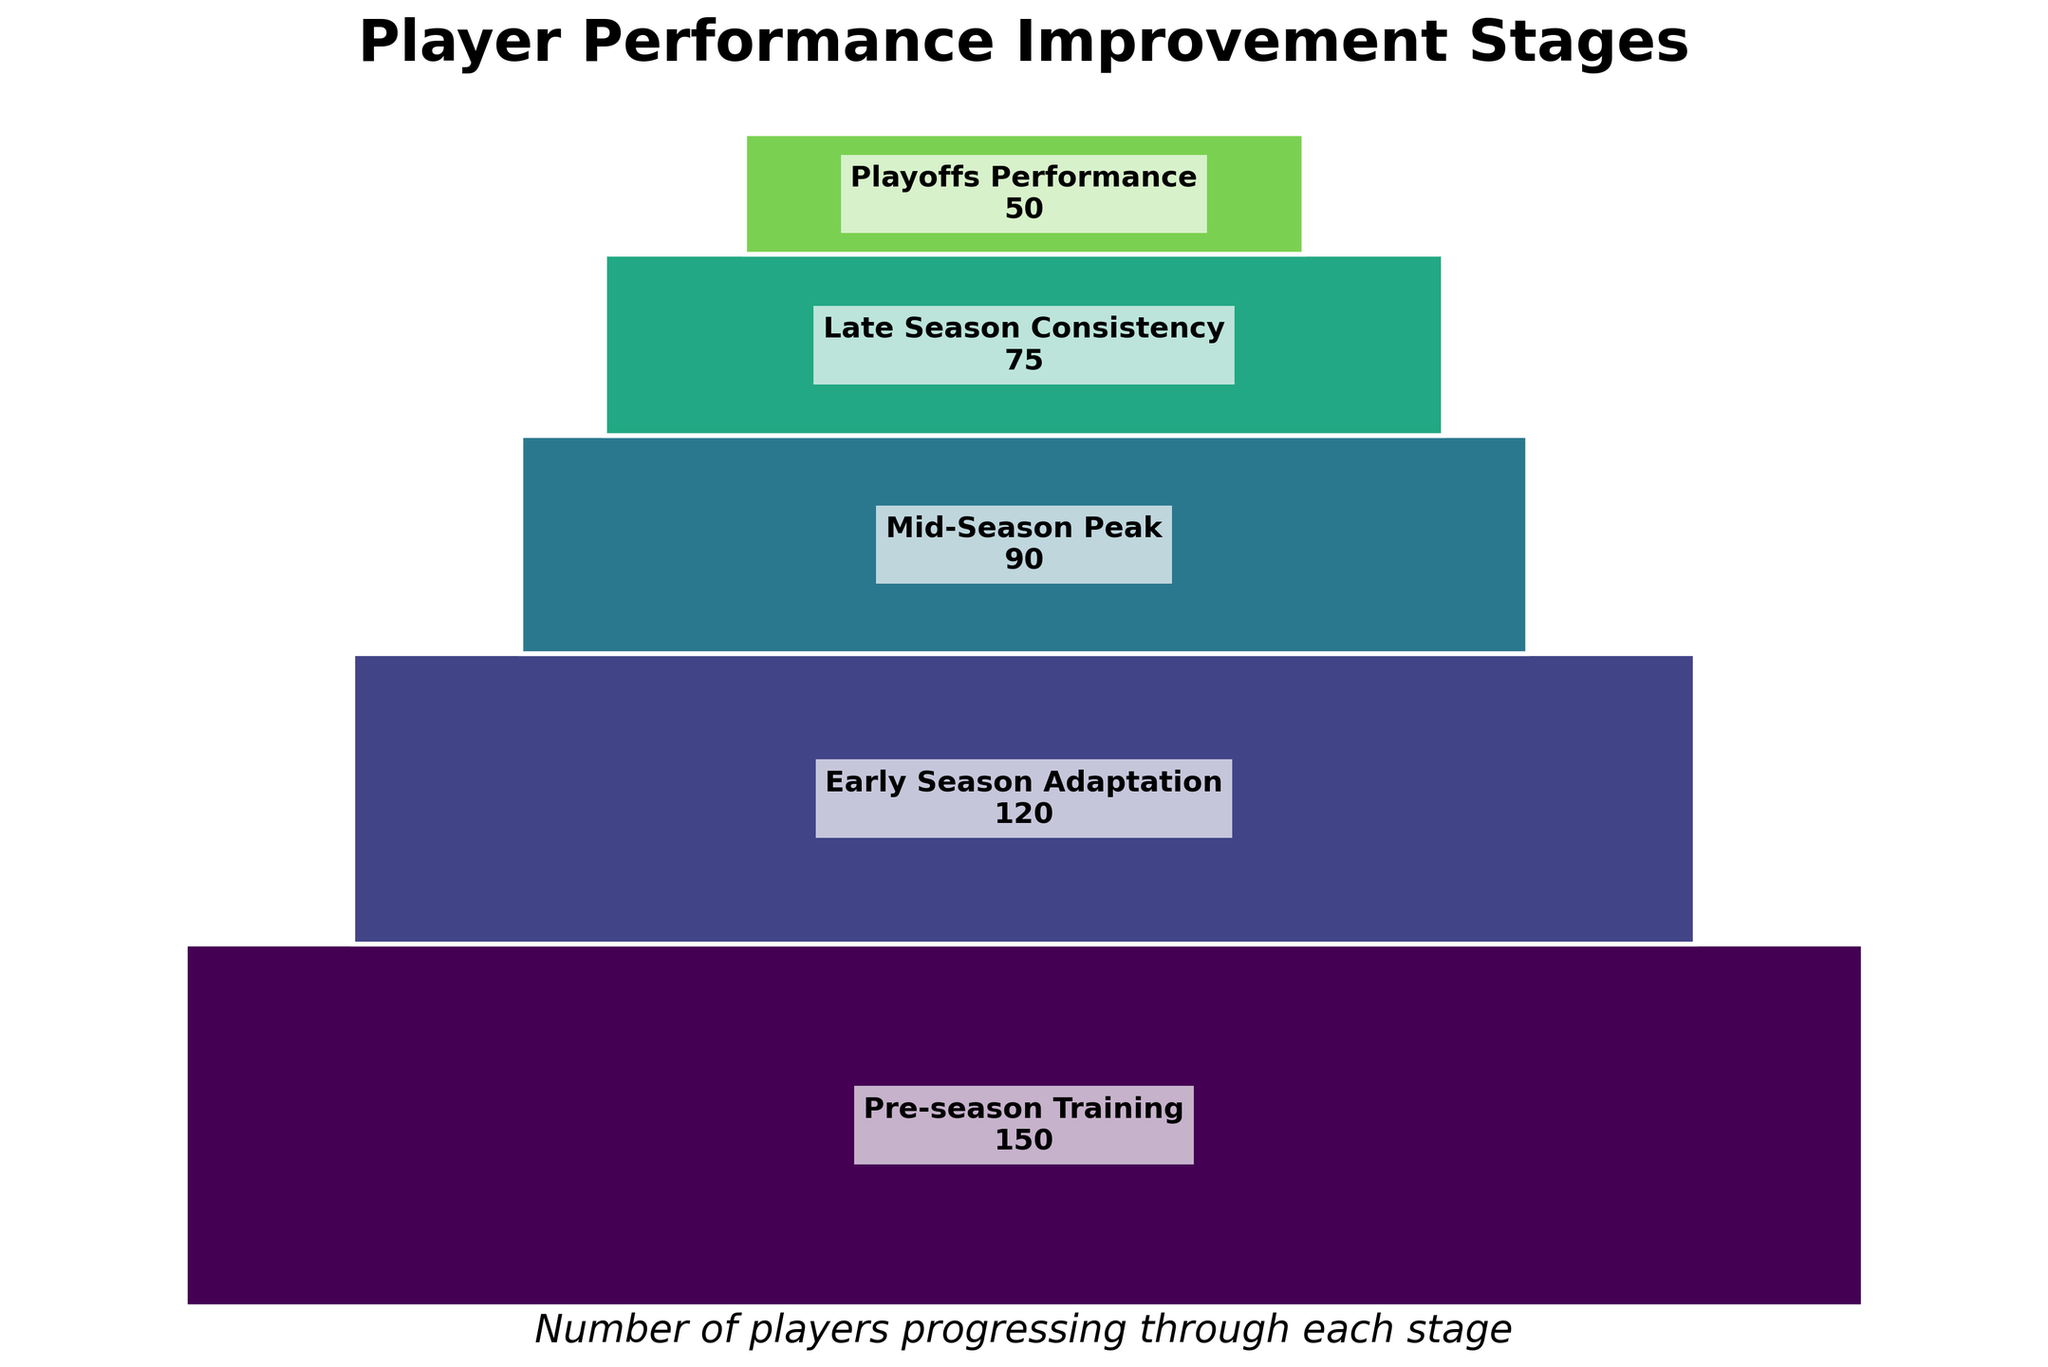What's the title of the figure? The title is clearly displayed at the top of the figure. It reads "Player Performance Improvement Stages".
Answer: Player Performance Improvement Stages How many stages are shown on the funnel chart? Count the number of distinct stages listed on the chart. There are five stages shown.
Answer: 5 What is the number of players at the Mid-Season Peak stage? Look for the label "Mid-Season Peak" and read the number next to it. The number of players at this stage is 90.
Answer: 90 Which stage has the fewest number of players, and how many players are at this stage? The narrowest section of the funnel represents the stage with the fewest players. The "Playoffs Performance" stage has the fewest players, with 50 players.
Answer: Playoffs Performance, 50 How many players drop out between Pre-season Training and Early Season Adaptation stages? Subtract the number of players in the Early Season Adaptation stage from the Pre-season Training stage. The calculation is 150 - 120 = 30 players.
Answer: 30 Calculate the total number of players who did not progress to the Playoffs Performance stage. Subtract the number of players in the Playoffs Performance stage from the number of players in the Pre-season Training stage. The calculation is 150 - 50 = 100 players.
Answer: 100 Compare the number of players in the Early Season Adaptation and Late Season Consistency stages. Which stage has more players and by how many? Subtract the number of players in the Late Season Consistency stage from the Early Season Adaptation stage to find the difference. The calculation is 120 - 75 = 45. The Early Season Adaptation stage has 45 more players.
Answer: Early Season Adaptation by 45 What percentage of the original players (Pre-season Training) make it to the Playoffs Performance stage? Divide the number of players in the Playoffs Performance stage (50) by the number of players in the Pre-season Training stage (150) and then multiply by 100 to get the percentage. The calculation is (50 / 150) * 100 = 33.33%.
Answer: 33.33% Between which two consecutive stages is the largest drop in the number of players? Calculate the drop between each pair of consecutive stages and find the maximum: 
- Pre-season Training to Early Season Adaptation: 150 - 120 = 30
- Early Season Adaptation to Mid-Season Peak: 120 - 90 = 30
- Mid-Season Peak to Late Season Consistency: 90 - 75 = 15
- Late Season Consistency to Playoffs Performance: 75 - 50 = 25
The largest drop is between Early Season Adaptation and Mid-Season Peak (30 players), although it is mathematically tied with the drop from Pre-season Training to Early Season Adaptation.
Answer: Pre-season Training to Early Season Adaptation (or) Early Season Adaptation to Mid-Season Peak What are the colors used to represent different stages in the funnel chart? Observe the chart and note the colors used. Each stage is represented by a different shade of color from a gradient, typically starting from a lighter to a darker shade as it moves down the stages.
Answer: Gradient of shades (no specific color names given) 